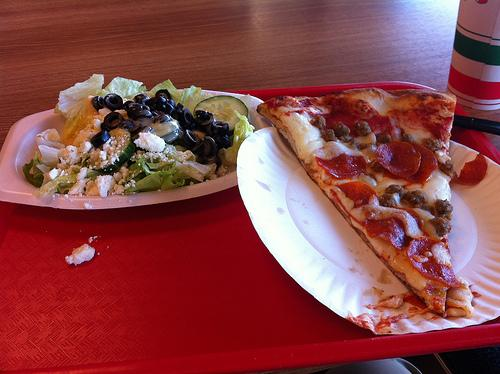Examine the image and identify what the tray and table colors are. The tray is red, and the table appears to be wooden. Point out the essential components of the salad in the image and their major ingredients. The salad includes lettuce, cucumbers, feta cheese, and black olives; it is served in a pink bowl on a red tray. Identify the main dish in the image and its prominent toppings. The main dish is a slice of pizza with sausage and pepperoni as prominent toppings. What type of sides and drink is included with the pizza in the picture? The picture includes a side salad with cucumbers, black olives, and feta cheese, and a beverage cup with Italian colors. Describe the plate the pizza is served on and its positioning. The pizza is served on a white round plastic plate, which is placed on a red tray. How many sliced black olives are visible on the salad? There are two slices of black olives visible on the salad. Analyze the overall sentiment conveyed by the image. The image conveys a positive sentiment, showing a delicious and satisfying meal of pizza, salad, and a drink. Count the number of sausage pieces on the pizza. There are three pieces of sausage on the pizza. Describe a distinct feature of the beverage cup in the image. The beverage cup is white with two stripes and Italian colors. What is the shape of the pizza slice? The pizza slice is shaped like a triangle. 